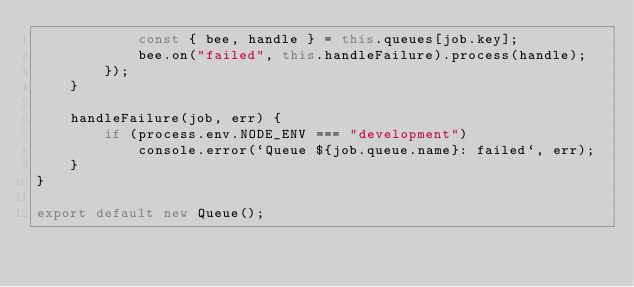<code> <loc_0><loc_0><loc_500><loc_500><_JavaScript_>            const { bee, handle } = this.queues[job.key];
            bee.on("failed", this.handleFailure).process(handle);
        });
    }

    handleFailure(job, err) {
        if (process.env.NODE_ENV === "development")
            console.error(`Queue ${job.queue.name}: failed`, err);
    }
}

export default new Queue();
</code> 